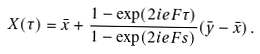<formula> <loc_0><loc_0><loc_500><loc_500>X ( \tau ) = \bar { x } + \frac { 1 - \exp ( 2 i e F \tau ) } { 1 - \exp ( 2 i e F s ) } ( \bar { y } - \bar { x } ) \, .</formula> 